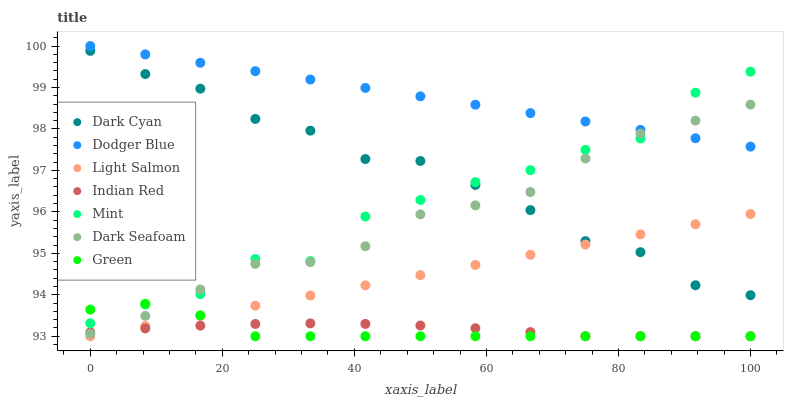Does Green have the minimum area under the curve?
Answer yes or no. Yes. Does Dodger Blue have the maximum area under the curve?
Answer yes or no. Yes. Does Dark Seafoam have the minimum area under the curve?
Answer yes or no. No. Does Dark Seafoam have the maximum area under the curve?
Answer yes or no. No. Is Light Salmon the smoothest?
Answer yes or no. Yes. Is Mint the roughest?
Answer yes or no. Yes. Is Dark Seafoam the smoothest?
Answer yes or no. No. Is Dark Seafoam the roughest?
Answer yes or no. No. Does Light Salmon have the lowest value?
Answer yes or no. Yes. Does Dark Seafoam have the lowest value?
Answer yes or no. No. Does Dodger Blue have the highest value?
Answer yes or no. Yes. Does Dark Seafoam have the highest value?
Answer yes or no. No. Is Green less than Dodger Blue?
Answer yes or no. Yes. Is Dodger Blue greater than Light Salmon?
Answer yes or no. Yes. Does Green intersect Light Salmon?
Answer yes or no. Yes. Is Green less than Light Salmon?
Answer yes or no. No. Is Green greater than Light Salmon?
Answer yes or no. No. Does Green intersect Dodger Blue?
Answer yes or no. No. 